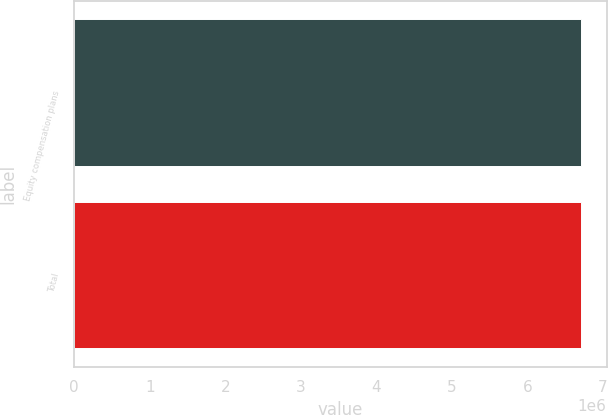Convert chart. <chart><loc_0><loc_0><loc_500><loc_500><bar_chart><fcel>Equity compensation plans<fcel>Total<nl><fcel>6.71397e+06<fcel>6.71397e+06<nl></chart> 